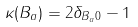<formula> <loc_0><loc_0><loc_500><loc_500>\kappa ( B _ { a } ) = 2 \delta _ { B _ { a } 0 } - 1</formula> 